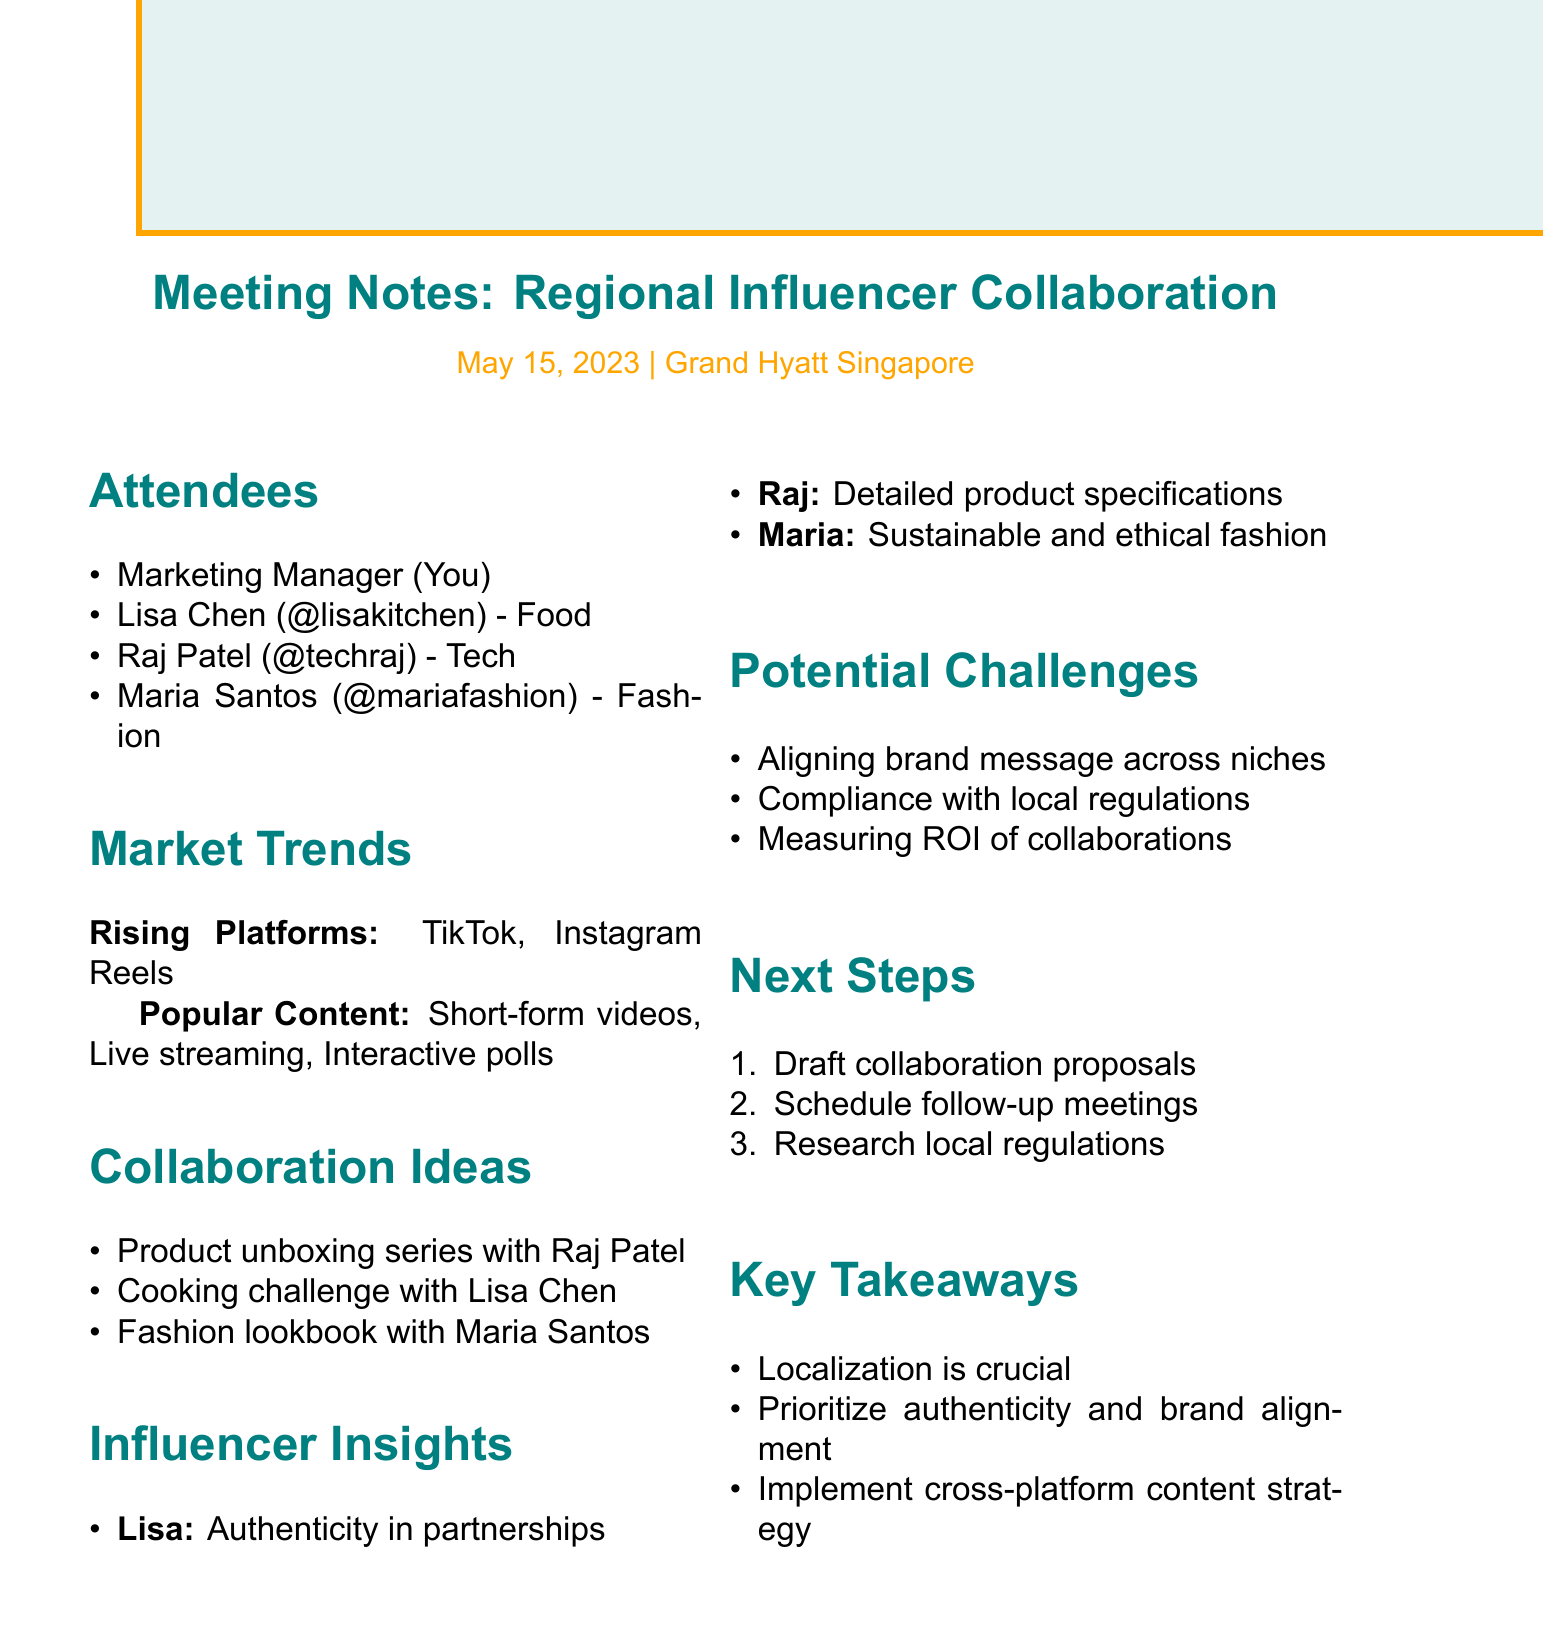What is the date of the meeting? The date of the meeting is specified in the document.
Answer: May 15, 2023 Who is the fashion influencer mentioned? The document lists attendees, including the fashion influencer.
Answer: Maria Santos What type of content is popular according to the trends? The document indicates different content formats that are currently popular.
Answer: Short-form videos What collaboration idea involves Lisa Chen? The document outlines potential collaboration ideas and specifies one involving Lisa Chen.
Answer: Cooking challenge using our products What challenge relates to brand message? The potential challenges listed in the document highlight issues related to brand messaging.
Answer: Aligning brand message across diverse influencer niches How many influencers attended the meeting? The number of attendees in the document includes influencers and the marketing manager.
Answer: Three influencers What is emphasized by Lisa Chen regarding brand partnerships? The document specifies insights from each influencer, including Lisa Chen's view on brand partnerships.
Answer: Authenticity What is one of the next steps mentioned? The document outlines next steps after the meeting, which requires drafting proposals.
Answer: Draft collaboration proposals for each influencer What is a key takeaway related to influencer partnerships? The document provides key takeaways related to the effectiveness of influencer partnerships.
Answer: Localization is crucial for successful influencer partnerships 